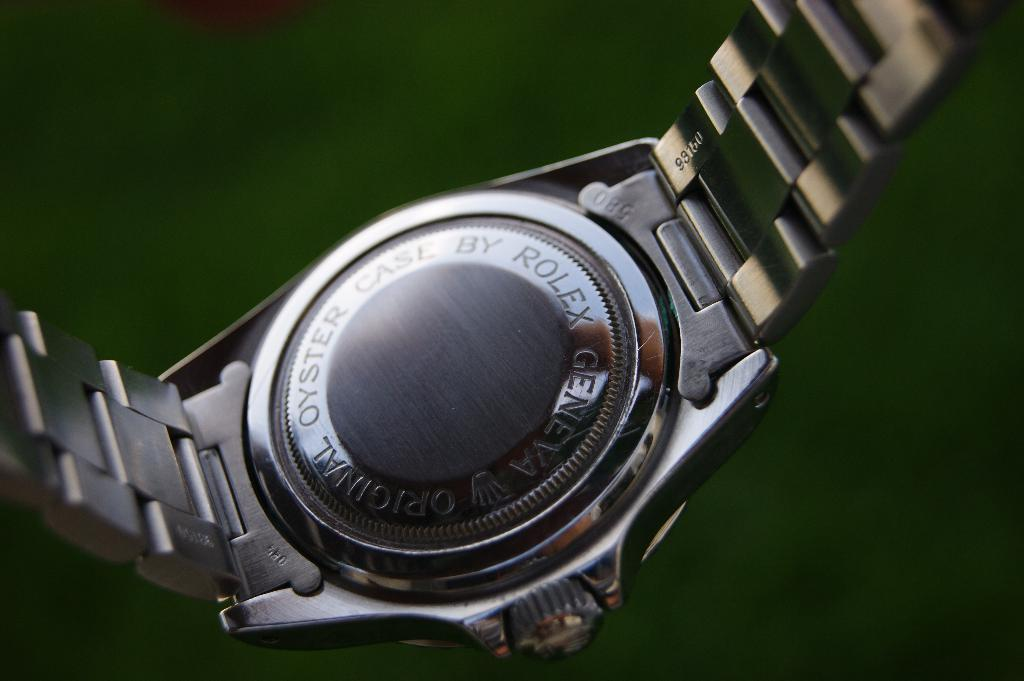Provide a one-sentence caption for the provided image. The back of the Rolex watch is being shown above a green background. 